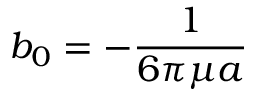Convert formula to latex. <formula><loc_0><loc_0><loc_500><loc_500>b _ { 0 } = - { \frac { 1 } { 6 \pi \mu a } }</formula> 